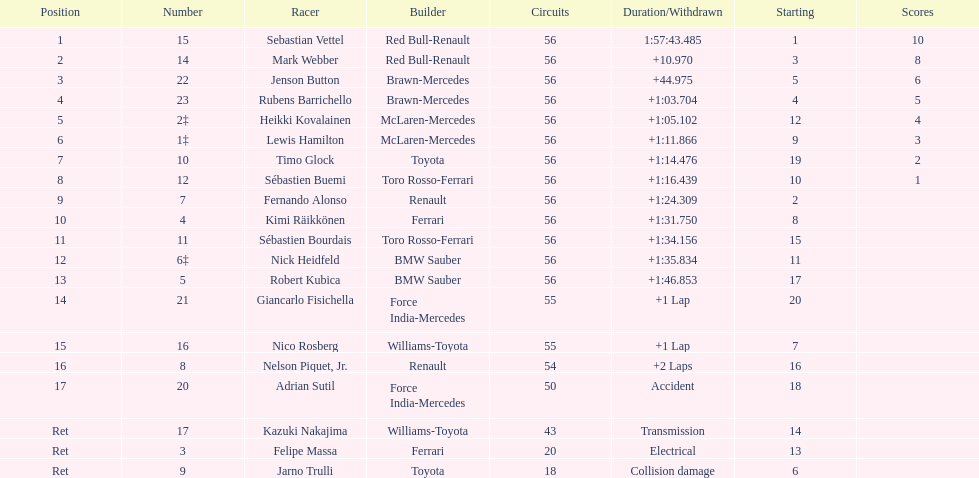How many laps in total is the race? 56. 